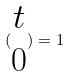Convert formula to latex. <formula><loc_0><loc_0><loc_500><loc_500>( \begin{matrix} t \\ 0 \end{matrix} ) = 1</formula> 